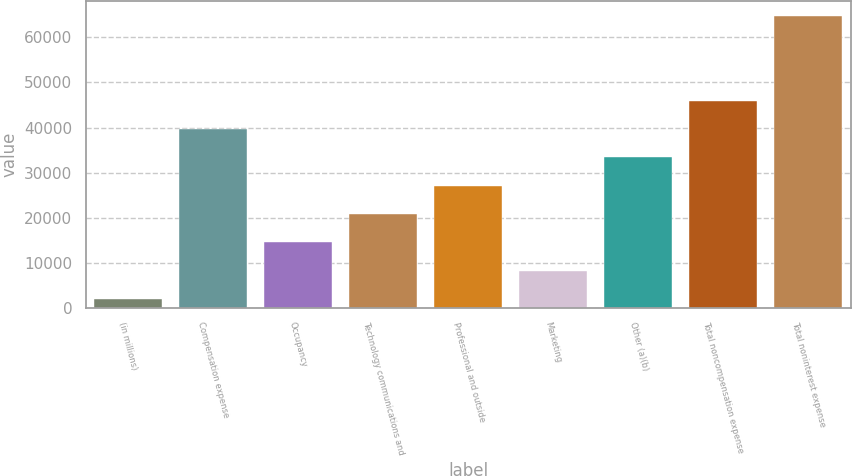<chart> <loc_0><loc_0><loc_500><loc_500><bar_chart><fcel>(in millions)<fcel>Compensation expense<fcel>Occupancy<fcel>Technology communications and<fcel>Professional and outside<fcel>Marketing<fcel>Other (a)(b)<fcel>Total noncompensation expense<fcel>Total noninterest expense<nl><fcel>2012<fcel>39642.2<fcel>14555.4<fcel>20827.1<fcel>27098.8<fcel>8283.7<fcel>33370.5<fcel>45913.9<fcel>64729<nl></chart> 